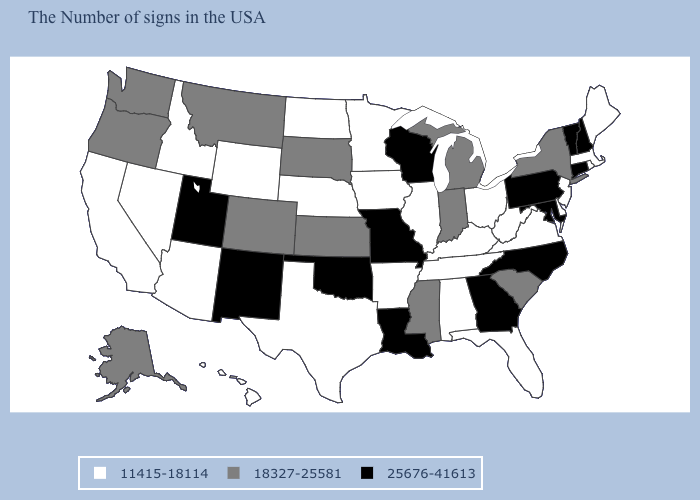Name the states that have a value in the range 18327-25581?
Write a very short answer. New York, South Carolina, Michigan, Indiana, Mississippi, Kansas, South Dakota, Colorado, Montana, Washington, Oregon, Alaska. What is the highest value in the USA?
Write a very short answer. 25676-41613. What is the value of Massachusetts?
Answer briefly. 11415-18114. Name the states that have a value in the range 11415-18114?
Answer briefly. Maine, Massachusetts, Rhode Island, New Jersey, Delaware, Virginia, West Virginia, Ohio, Florida, Kentucky, Alabama, Tennessee, Illinois, Arkansas, Minnesota, Iowa, Nebraska, Texas, North Dakota, Wyoming, Arizona, Idaho, Nevada, California, Hawaii. Name the states that have a value in the range 25676-41613?
Answer briefly. New Hampshire, Vermont, Connecticut, Maryland, Pennsylvania, North Carolina, Georgia, Wisconsin, Louisiana, Missouri, Oklahoma, New Mexico, Utah. Name the states that have a value in the range 18327-25581?
Quick response, please. New York, South Carolina, Michigan, Indiana, Mississippi, Kansas, South Dakota, Colorado, Montana, Washington, Oregon, Alaska. Name the states that have a value in the range 25676-41613?
Keep it brief. New Hampshire, Vermont, Connecticut, Maryland, Pennsylvania, North Carolina, Georgia, Wisconsin, Louisiana, Missouri, Oklahoma, New Mexico, Utah. What is the lowest value in the South?
Write a very short answer. 11415-18114. Among the states that border Alabama , which have the lowest value?
Write a very short answer. Florida, Tennessee. What is the lowest value in the USA?
Keep it brief. 11415-18114. Name the states that have a value in the range 11415-18114?
Keep it brief. Maine, Massachusetts, Rhode Island, New Jersey, Delaware, Virginia, West Virginia, Ohio, Florida, Kentucky, Alabama, Tennessee, Illinois, Arkansas, Minnesota, Iowa, Nebraska, Texas, North Dakota, Wyoming, Arizona, Idaho, Nevada, California, Hawaii. Name the states that have a value in the range 25676-41613?
Write a very short answer. New Hampshire, Vermont, Connecticut, Maryland, Pennsylvania, North Carolina, Georgia, Wisconsin, Louisiana, Missouri, Oklahoma, New Mexico, Utah. Does Texas have a higher value than New Mexico?
Answer briefly. No. Among the states that border Massachusetts , which have the highest value?
Give a very brief answer. New Hampshire, Vermont, Connecticut. Name the states that have a value in the range 11415-18114?
Quick response, please. Maine, Massachusetts, Rhode Island, New Jersey, Delaware, Virginia, West Virginia, Ohio, Florida, Kentucky, Alabama, Tennessee, Illinois, Arkansas, Minnesota, Iowa, Nebraska, Texas, North Dakota, Wyoming, Arizona, Idaho, Nevada, California, Hawaii. 